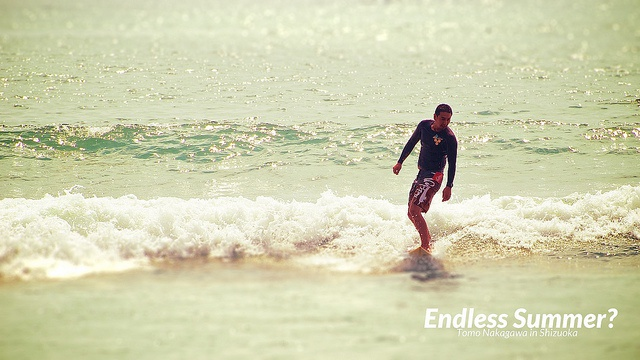Describe the objects in this image and their specific colors. I can see people in tan, black, maroon, brown, and purple tones, surfboard in tan and brown tones, and people in tan, beige, and darkgray tones in this image. 